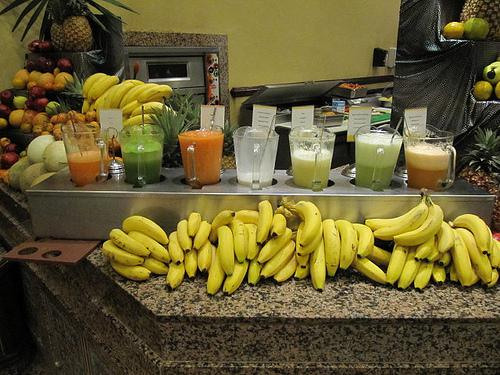Question: why the bananas on the counter?
Choices:
A. To be sold.
B. To be eaten.
C. As free samples.
D. For display.
Answer with the letter. Answer: D Question: who is drinking the juices?
Choices:
A. No one.
B. 1 man.
C. Some kids.
D. An old woman.
Answer with the letter. Answer: A Question: what is on the counter?
Choices:
A. Placemats.
B. Glasses.
C. Bananas.
D. Menus.
Answer with the letter. Answer: C Question: how many pitchers in the counter?
Choices:
A. 7.
B. 3.
C. 2.
D. 1.
Answer with the letter. Answer: A Question: what is the color of the bananas?
Choices:
A. Brown.
B. Black.
C. Yellow.
D. Greenish.
Answer with the letter. Answer: C 